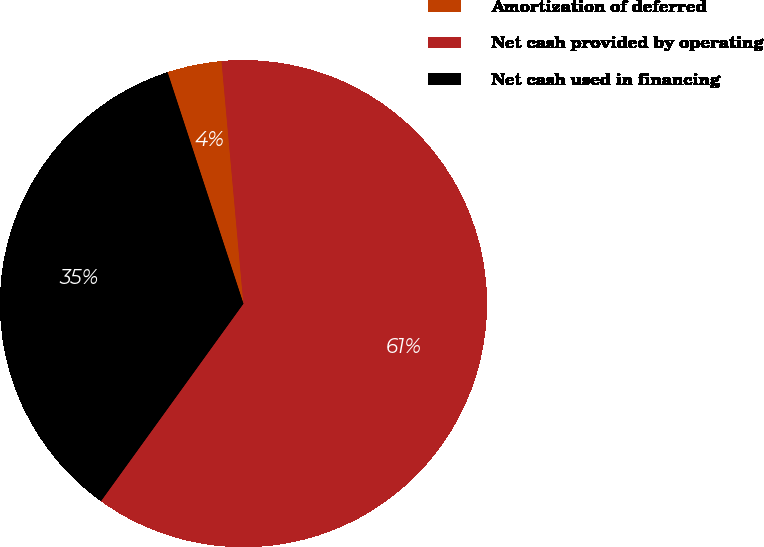Convert chart to OTSL. <chart><loc_0><loc_0><loc_500><loc_500><pie_chart><fcel>Amortization of deferred<fcel>Net cash provided by operating<fcel>Net cash used in financing<nl><fcel>3.61%<fcel>61.38%<fcel>35.01%<nl></chart> 